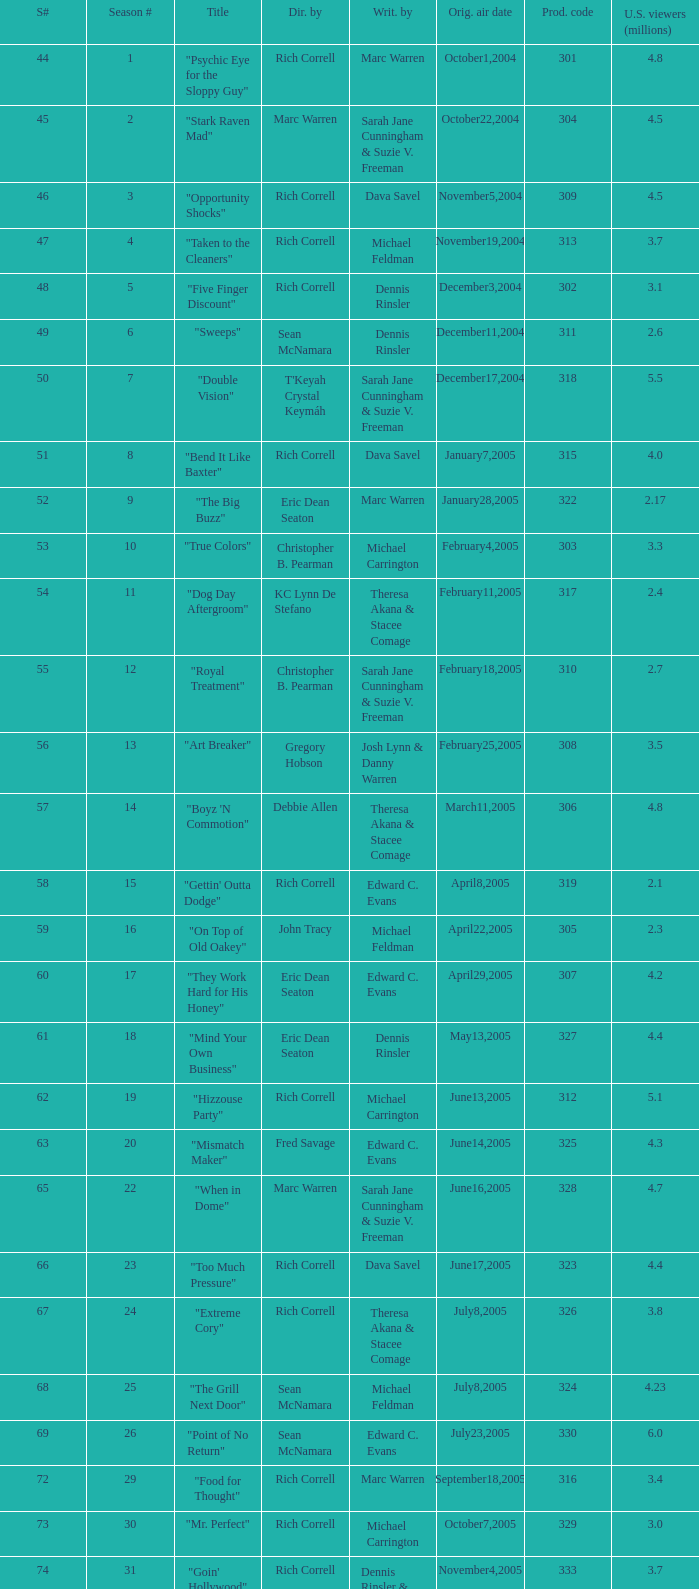What number episode in the season had a production code of 334? 32.0. 